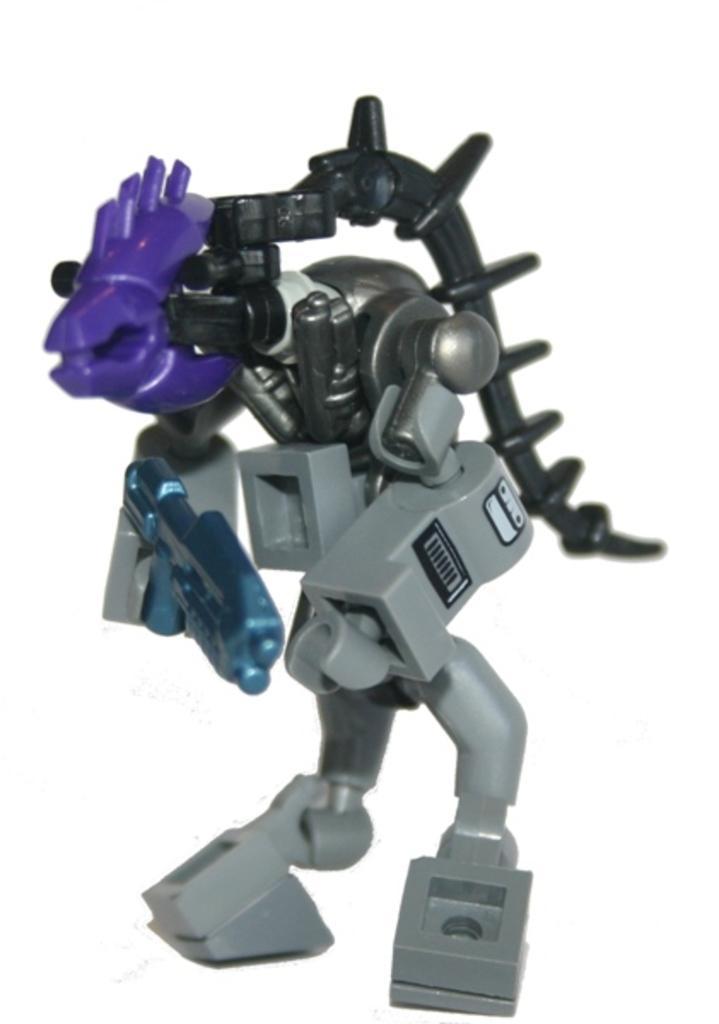Please provide a concise description of this image. In this picture we can see a toy and there is a white background. 